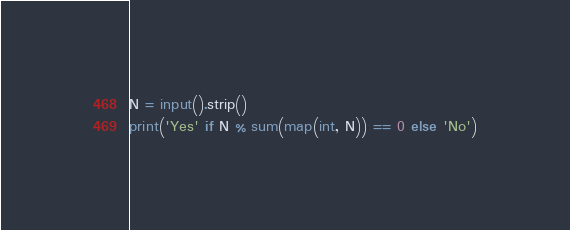<code> <loc_0><loc_0><loc_500><loc_500><_Python_>N = input().strip()
print('Yes' if N % sum(map(int, N)) == 0 else 'No')
</code> 